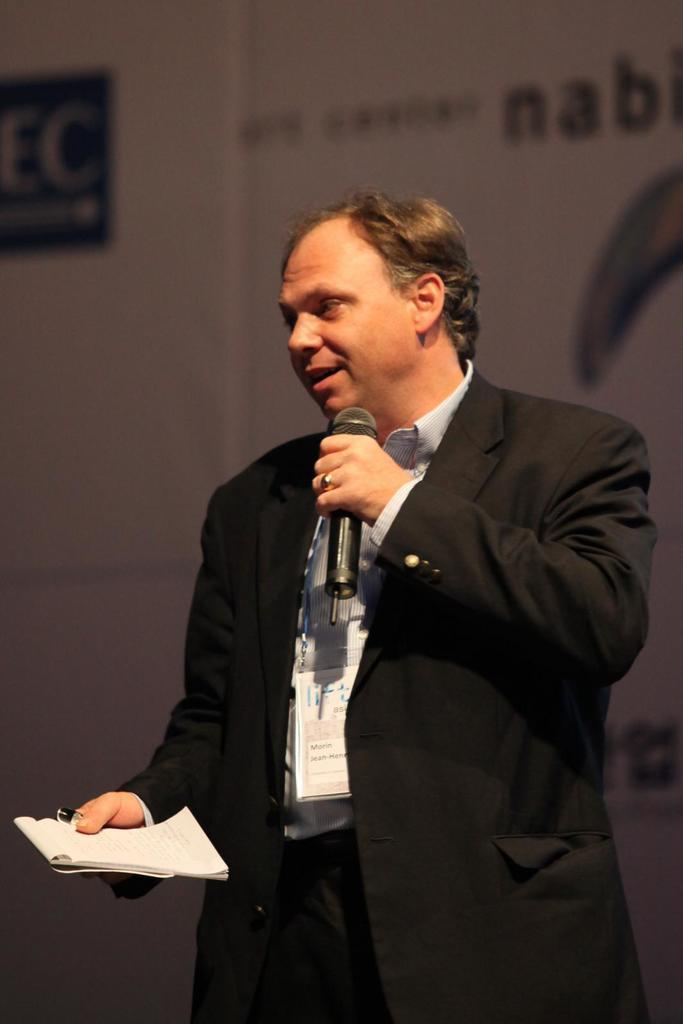Who is the main subject in the image? There is a man in the image. What is the man doing in the image? The man is standing and appears to be talking. What objects is the man holding in the image? The man is holding a book and a microphone. Can you see the man holding a rifle in the image? No, there is no rifle present in the image. The man is holding a book and a microphone. 